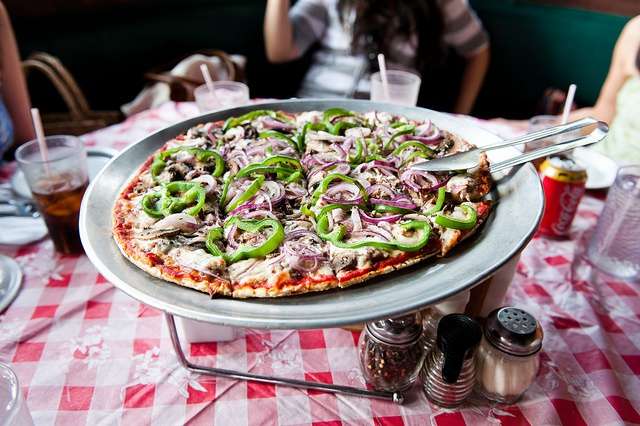Describe the objects in this image and their specific colors. I can see pizza in black, lightgray, tan, and beige tones, people in black, gray, maroon, and darkgray tones, cup in black, darkgray, and maroon tones, people in black, ivory, tan, and darkgray tones, and chair in black, maroon, and gray tones in this image. 